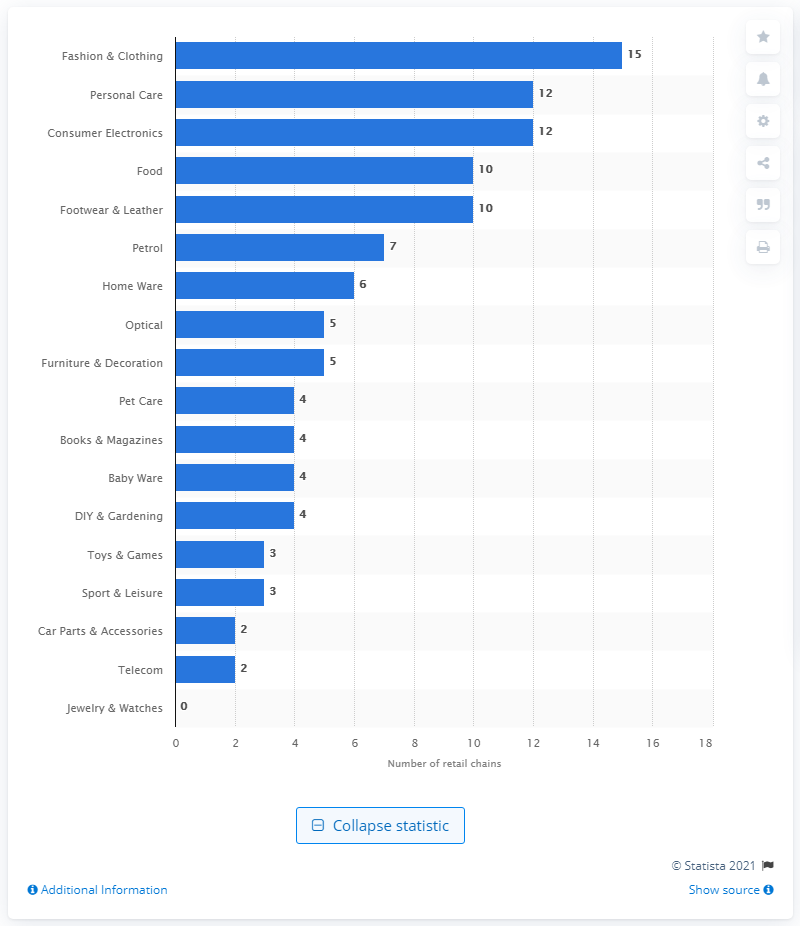Highlight a few significant elements in this photo. As of the year 2020, there were 10 retail chains operating in Latvia. 